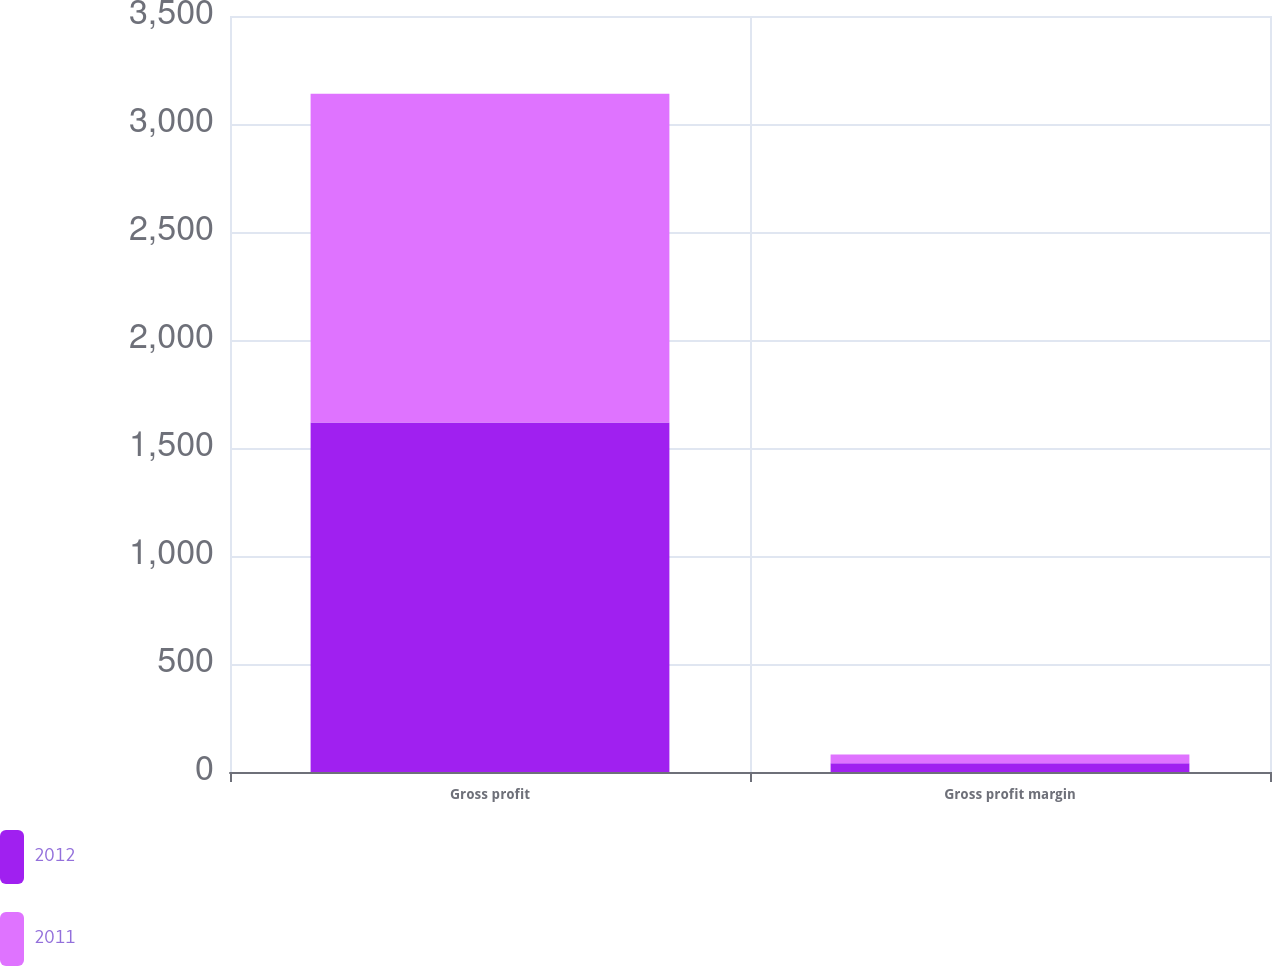Convert chart. <chart><loc_0><loc_0><loc_500><loc_500><stacked_bar_chart><ecel><fcel>Gross profit<fcel>Gross profit margin<nl><fcel>2012<fcel>1617.8<fcel>40.3<nl><fcel>2011<fcel>1522.5<fcel>41.2<nl></chart> 